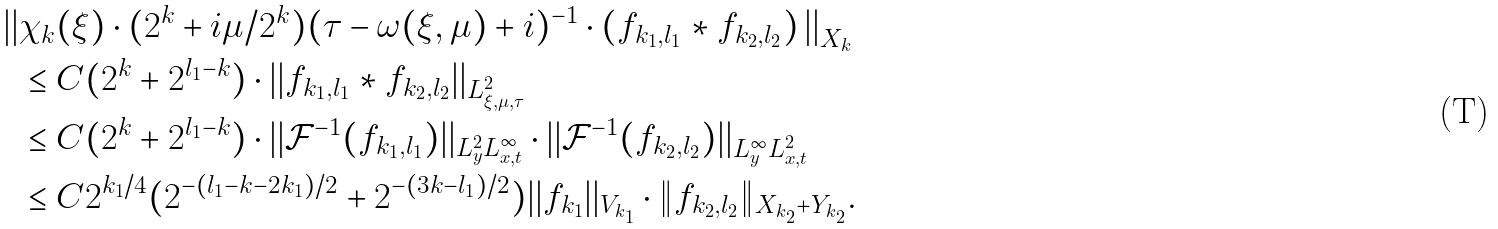Convert formula to latex. <formula><loc_0><loc_0><loc_500><loc_500>\left | \right | & \chi _ { k } ( \xi ) \cdot ( 2 ^ { k } + i \mu / 2 ^ { k } ) ( \tau - \omega ( \xi , \mu ) + i ) ^ { - 1 } \cdot ( f _ { k _ { 1 } , l _ { 1 } } \ast f _ { k _ { 2 } , l _ { 2 } } ) \left | \right | _ { X _ { k } } \\ & \leq C ( 2 ^ { k } + 2 ^ { l _ { 1 } - k } ) \cdot | | f _ { k _ { 1 } , l _ { 1 } } \ast f _ { k _ { 2 } , l _ { 2 } } | | _ { L ^ { 2 } _ { \xi , \mu , \tau } } \\ & \leq C ( 2 ^ { k } + 2 ^ { l _ { 1 } - k } ) \cdot | | \mathcal { F } ^ { - 1 } ( f _ { k _ { 1 } , l _ { 1 } } ) | | _ { L ^ { 2 } _ { y } L ^ { \infty } _ { x , t } } \cdot | | \mathcal { F } ^ { - 1 } ( f _ { k _ { 2 } , l _ { 2 } } ) | | _ { L ^ { \infty } _ { y } L ^ { 2 } _ { x , t } } \\ & \leq C 2 ^ { k _ { 1 } / 4 } ( 2 ^ { - ( l _ { 1 } - k - 2 k _ { 1 } ) / 2 } + 2 ^ { - ( 3 k - l _ { 1 } ) / 2 } ) | | f _ { k _ { 1 } } | | _ { V _ { k _ { 1 } } } \cdot \| f _ { k _ { 2 } , l _ { 2 } } \| _ { X _ { k _ { 2 } } + Y _ { k _ { 2 } } } .</formula> 